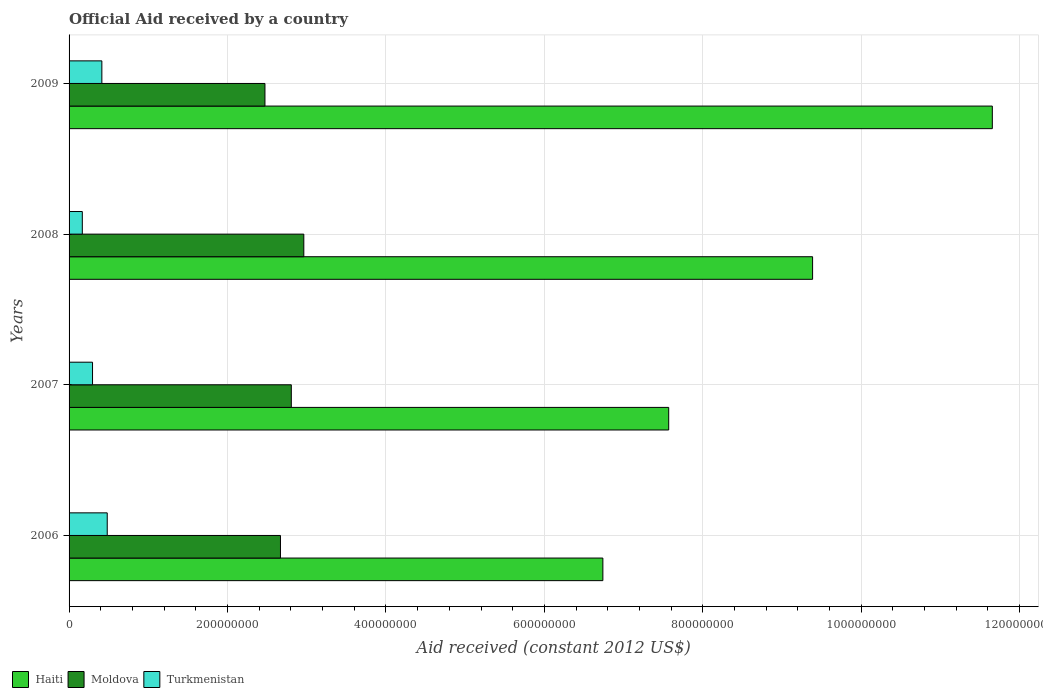How many groups of bars are there?
Offer a very short reply. 4. How many bars are there on the 2nd tick from the top?
Provide a succinct answer. 3. In how many cases, is the number of bars for a given year not equal to the number of legend labels?
Offer a terse response. 0. What is the net official aid received in Haiti in 2008?
Keep it short and to the point. 9.39e+08. Across all years, what is the maximum net official aid received in Turkmenistan?
Ensure brevity in your answer.  4.82e+07. Across all years, what is the minimum net official aid received in Turkmenistan?
Give a very brief answer. 1.67e+07. In which year was the net official aid received in Haiti minimum?
Your answer should be very brief. 2006. What is the total net official aid received in Turkmenistan in the graph?
Your answer should be compact. 1.36e+08. What is the difference between the net official aid received in Haiti in 2008 and that in 2009?
Your response must be concise. -2.27e+08. What is the difference between the net official aid received in Haiti in 2006 and the net official aid received in Turkmenistan in 2009?
Provide a succinct answer. 6.32e+08. What is the average net official aid received in Haiti per year?
Keep it short and to the point. 8.84e+08. In the year 2007, what is the difference between the net official aid received in Haiti and net official aid received in Moldova?
Offer a very short reply. 4.76e+08. What is the ratio of the net official aid received in Moldova in 2006 to that in 2007?
Provide a succinct answer. 0.95. What is the difference between the highest and the second highest net official aid received in Turkmenistan?
Offer a very short reply. 6.78e+06. What is the difference between the highest and the lowest net official aid received in Haiti?
Provide a short and direct response. 4.92e+08. In how many years, is the net official aid received in Moldova greater than the average net official aid received in Moldova taken over all years?
Your response must be concise. 2. What does the 2nd bar from the top in 2009 represents?
Your response must be concise. Moldova. What does the 1st bar from the bottom in 2006 represents?
Keep it short and to the point. Haiti. Are all the bars in the graph horizontal?
Offer a very short reply. Yes. How many years are there in the graph?
Provide a succinct answer. 4. What is the difference between two consecutive major ticks on the X-axis?
Your answer should be compact. 2.00e+08. Are the values on the major ticks of X-axis written in scientific E-notation?
Give a very brief answer. No. How are the legend labels stacked?
Keep it short and to the point. Horizontal. What is the title of the graph?
Provide a succinct answer. Official Aid received by a country. What is the label or title of the X-axis?
Your answer should be compact. Aid received (constant 2012 US$). What is the label or title of the Y-axis?
Your response must be concise. Years. What is the Aid received (constant 2012 US$) in Haiti in 2006?
Your answer should be compact. 6.74e+08. What is the Aid received (constant 2012 US$) in Moldova in 2006?
Offer a very short reply. 2.67e+08. What is the Aid received (constant 2012 US$) in Turkmenistan in 2006?
Make the answer very short. 4.82e+07. What is the Aid received (constant 2012 US$) in Haiti in 2007?
Your answer should be very brief. 7.57e+08. What is the Aid received (constant 2012 US$) of Moldova in 2007?
Provide a short and direct response. 2.81e+08. What is the Aid received (constant 2012 US$) of Turkmenistan in 2007?
Ensure brevity in your answer.  2.96e+07. What is the Aid received (constant 2012 US$) in Haiti in 2008?
Give a very brief answer. 9.39e+08. What is the Aid received (constant 2012 US$) in Moldova in 2008?
Provide a succinct answer. 2.96e+08. What is the Aid received (constant 2012 US$) of Turkmenistan in 2008?
Provide a short and direct response. 1.67e+07. What is the Aid received (constant 2012 US$) of Haiti in 2009?
Your response must be concise. 1.17e+09. What is the Aid received (constant 2012 US$) in Moldova in 2009?
Offer a very short reply. 2.47e+08. What is the Aid received (constant 2012 US$) of Turkmenistan in 2009?
Provide a succinct answer. 4.14e+07. Across all years, what is the maximum Aid received (constant 2012 US$) of Haiti?
Your answer should be very brief. 1.17e+09. Across all years, what is the maximum Aid received (constant 2012 US$) in Moldova?
Keep it short and to the point. 2.96e+08. Across all years, what is the maximum Aid received (constant 2012 US$) in Turkmenistan?
Give a very brief answer. 4.82e+07. Across all years, what is the minimum Aid received (constant 2012 US$) of Haiti?
Your response must be concise. 6.74e+08. Across all years, what is the minimum Aid received (constant 2012 US$) of Moldova?
Provide a short and direct response. 2.47e+08. Across all years, what is the minimum Aid received (constant 2012 US$) in Turkmenistan?
Offer a very short reply. 1.67e+07. What is the total Aid received (constant 2012 US$) of Haiti in the graph?
Make the answer very short. 3.53e+09. What is the total Aid received (constant 2012 US$) of Moldova in the graph?
Provide a succinct answer. 1.09e+09. What is the total Aid received (constant 2012 US$) of Turkmenistan in the graph?
Your answer should be compact. 1.36e+08. What is the difference between the Aid received (constant 2012 US$) of Haiti in 2006 and that in 2007?
Give a very brief answer. -8.31e+07. What is the difference between the Aid received (constant 2012 US$) in Moldova in 2006 and that in 2007?
Your response must be concise. -1.37e+07. What is the difference between the Aid received (constant 2012 US$) of Turkmenistan in 2006 and that in 2007?
Ensure brevity in your answer.  1.86e+07. What is the difference between the Aid received (constant 2012 US$) in Haiti in 2006 and that in 2008?
Offer a terse response. -2.65e+08. What is the difference between the Aid received (constant 2012 US$) in Moldova in 2006 and that in 2008?
Your answer should be compact. -2.95e+07. What is the difference between the Aid received (constant 2012 US$) of Turkmenistan in 2006 and that in 2008?
Keep it short and to the point. 3.15e+07. What is the difference between the Aid received (constant 2012 US$) of Haiti in 2006 and that in 2009?
Ensure brevity in your answer.  -4.92e+08. What is the difference between the Aid received (constant 2012 US$) in Moldova in 2006 and that in 2009?
Provide a succinct answer. 1.96e+07. What is the difference between the Aid received (constant 2012 US$) of Turkmenistan in 2006 and that in 2009?
Your answer should be very brief. 6.78e+06. What is the difference between the Aid received (constant 2012 US$) in Haiti in 2007 and that in 2008?
Offer a terse response. -1.82e+08. What is the difference between the Aid received (constant 2012 US$) in Moldova in 2007 and that in 2008?
Offer a very short reply. -1.58e+07. What is the difference between the Aid received (constant 2012 US$) in Turkmenistan in 2007 and that in 2008?
Offer a terse response. 1.29e+07. What is the difference between the Aid received (constant 2012 US$) in Haiti in 2007 and that in 2009?
Your answer should be compact. -4.09e+08. What is the difference between the Aid received (constant 2012 US$) of Moldova in 2007 and that in 2009?
Provide a short and direct response. 3.33e+07. What is the difference between the Aid received (constant 2012 US$) in Turkmenistan in 2007 and that in 2009?
Provide a succinct answer. -1.18e+07. What is the difference between the Aid received (constant 2012 US$) of Haiti in 2008 and that in 2009?
Keep it short and to the point. -2.27e+08. What is the difference between the Aid received (constant 2012 US$) in Moldova in 2008 and that in 2009?
Offer a terse response. 4.91e+07. What is the difference between the Aid received (constant 2012 US$) in Turkmenistan in 2008 and that in 2009?
Keep it short and to the point. -2.47e+07. What is the difference between the Aid received (constant 2012 US$) of Haiti in 2006 and the Aid received (constant 2012 US$) of Moldova in 2007?
Provide a succinct answer. 3.93e+08. What is the difference between the Aid received (constant 2012 US$) of Haiti in 2006 and the Aid received (constant 2012 US$) of Turkmenistan in 2007?
Offer a terse response. 6.44e+08. What is the difference between the Aid received (constant 2012 US$) of Moldova in 2006 and the Aid received (constant 2012 US$) of Turkmenistan in 2007?
Your answer should be compact. 2.37e+08. What is the difference between the Aid received (constant 2012 US$) of Haiti in 2006 and the Aid received (constant 2012 US$) of Moldova in 2008?
Provide a succinct answer. 3.78e+08. What is the difference between the Aid received (constant 2012 US$) of Haiti in 2006 and the Aid received (constant 2012 US$) of Turkmenistan in 2008?
Keep it short and to the point. 6.57e+08. What is the difference between the Aid received (constant 2012 US$) in Moldova in 2006 and the Aid received (constant 2012 US$) in Turkmenistan in 2008?
Keep it short and to the point. 2.50e+08. What is the difference between the Aid received (constant 2012 US$) in Haiti in 2006 and the Aid received (constant 2012 US$) in Moldova in 2009?
Give a very brief answer. 4.27e+08. What is the difference between the Aid received (constant 2012 US$) in Haiti in 2006 and the Aid received (constant 2012 US$) in Turkmenistan in 2009?
Provide a short and direct response. 6.32e+08. What is the difference between the Aid received (constant 2012 US$) in Moldova in 2006 and the Aid received (constant 2012 US$) in Turkmenistan in 2009?
Make the answer very short. 2.25e+08. What is the difference between the Aid received (constant 2012 US$) of Haiti in 2007 and the Aid received (constant 2012 US$) of Moldova in 2008?
Keep it short and to the point. 4.61e+08. What is the difference between the Aid received (constant 2012 US$) in Haiti in 2007 and the Aid received (constant 2012 US$) in Turkmenistan in 2008?
Offer a very short reply. 7.40e+08. What is the difference between the Aid received (constant 2012 US$) of Moldova in 2007 and the Aid received (constant 2012 US$) of Turkmenistan in 2008?
Your answer should be very brief. 2.64e+08. What is the difference between the Aid received (constant 2012 US$) in Haiti in 2007 and the Aid received (constant 2012 US$) in Moldova in 2009?
Keep it short and to the point. 5.10e+08. What is the difference between the Aid received (constant 2012 US$) of Haiti in 2007 and the Aid received (constant 2012 US$) of Turkmenistan in 2009?
Keep it short and to the point. 7.16e+08. What is the difference between the Aid received (constant 2012 US$) in Moldova in 2007 and the Aid received (constant 2012 US$) in Turkmenistan in 2009?
Ensure brevity in your answer.  2.39e+08. What is the difference between the Aid received (constant 2012 US$) of Haiti in 2008 and the Aid received (constant 2012 US$) of Moldova in 2009?
Your answer should be compact. 6.91e+08. What is the difference between the Aid received (constant 2012 US$) in Haiti in 2008 and the Aid received (constant 2012 US$) in Turkmenistan in 2009?
Give a very brief answer. 8.97e+08. What is the difference between the Aid received (constant 2012 US$) of Moldova in 2008 and the Aid received (constant 2012 US$) of Turkmenistan in 2009?
Your response must be concise. 2.55e+08. What is the average Aid received (constant 2012 US$) of Haiti per year?
Ensure brevity in your answer.  8.84e+08. What is the average Aid received (constant 2012 US$) of Moldova per year?
Provide a short and direct response. 2.73e+08. What is the average Aid received (constant 2012 US$) in Turkmenistan per year?
Make the answer very short. 3.40e+07. In the year 2006, what is the difference between the Aid received (constant 2012 US$) in Haiti and Aid received (constant 2012 US$) in Moldova?
Make the answer very short. 4.07e+08. In the year 2006, what is the difference between the Aid received (constant 2012 US$) of Haiti and Aid received (constant 2012 US$) of Turkmenistan?
Offer a terse response. 6.26e+08. In the year 2006, what is the difference between the Aid received (constant 2012 US$) in Moldova and Aid received (constant 2012 US$) in Turkmenistan?
Your response must be concise. 2.19e+08. In the year 2007, what is the difference between the Aid received (constant 2012 US$) of Haiti and Aid received (constant 2012 US$) of Moldova?
Your response must be concise. 4.76e+08. In the year 2007, what is the difference between the Aid received (constant 2012 US$) of Haiti and Aid received (constant 2012 US$) of Turkmenistan?
Ensure brevity in your answer.  7.27e+08. In the year 2007, what is the difference between the Aid received (constant 2012 US$) of Moldova and Aid received (constant 2012 US$) of Turkmenistan?
Your response must be concise. 2.51e+08. In the year 2008, what is the difference between the Aid received (constant 2012 US$) in Haiti and Aid received (constant 2012 US$) in Moldova?
Ensure brevity in your answer.  6.42e+08. In the year 2008, what is the difference between the Aid received (constant 2012 US$) of Haiti and Aid received (constant 2012 US$) of Turkmenistan?
Your answer should be compact. 9.22e+08. In the year 2008, what is the difference between the Aid received (constant 2012 US$) of Moldova and Aid received (constant 2012 US$) of Turkmenistan?
Offer a terse response. 2.80e+08. In the year 2009, what is the difference between the Aid received (constant 2012 US$) of Haiti and Aid received (constant 2012 US$) of Moldova?
Give a very brief answer. 9.18e+08. In the year 2009, what is the difference between the Aid received (constant 2012 US$) of Haiti and Aid received (constant 2012 US$) of Turkmenistan?
Your answer should be very brief. 1.12e+09. In the year 2009, what is the difference between the Aid received (constant 2012 US$) of Moldova and Aid received (constant 2012 US$) of Turkmenistan?
Make the answer very short. 2.06e+08. What is the ratio of the Aid received (constant 2012 US$) in Haiti in 2006 to that in 2007?
Your response must be concise. 0.89. What is the ratio of the Aid received (constant 2012 US$) of Moldova in 2006 to that in 2007?
Provide a succinct answer. 0.95. What is the ratio of the Aid received (constant 2012 US$) of Turkmenistan in 2006 to that in 2007?
Give a very brief answer. 1.63. What is the ratio of the Aid received (constant 2012 US$) of Haiti in 2006 to that in 2008?
Your response must be concise. 0.72. What is the ratio of the Aid received (constant 2012 US$) in Moldova in 2006 to that in 2008?
Provide a short and direct response. 0.9. What is the ratio of the Aid received (constant 2012 US$) in Turkmenistan in 2006 to that in 2008?
Your answer should be very brief. 2.88. What is the ratio of the Aid received (constant 2012 US$) of Haiti in 2006 to that in 2009?
Provide a succinct answer. 0.58. What is the ratio of the Aid received (constant 2012 US$) in Moldova in 2006 to that in 2009?
Give a very brief answer. 1.08. What is the ratio of the Aid received (constant 2012 US$) of Turkmenistan in 2006 to that in 2009?
Your answer should be compact. 1.16. What is the ratio of the Aid received (constant 2012 US$) in Haiti in 2007 to that in 2008?
Make the answer very short. 0.81. What is the ratio of the Aid received (constant 2012 US$) of Moldova in 2007 to that in 2008?
Your answer should be compact. 0.95. What is the ratio of the Aid received (constant 2012 US$) of Turkmenistan in 2007 to that in 2008?
Provide a short and direct response. 1.77. What is the ratio of the Aid received (constant 2012 US$) in Haiti in 2007 to that in 2009?
Your answer should be very brief. 0.65. What is the ratio of the Aid received (constant 2012 US$) in Moldova in 2007 to that in 2009?
Make the answer very short. 1.13. What is the ratio of the Aid received (constant 2012 US$) in Turkmenistan in 2007 to that in 2009?
Your answer should be very brief. 0.72. What is the ratio of the Aid received (constant 2012 US$) of Haiti in 2008 to that in 2009?
Your answer should be very brief. 0.81. What is the ratio of the Aid received (constant 2012 US$) in Moldova in 2008 to that in 2009?
Your answer should be very brief. 1.2. What is the ratio of the Aid received (constant 2012 US$) of Turkmenistan in 2008 to that in 2009?
Keep it short and to the point. 0.4. What is the difference between the highest and the second highest Aid received (constant 2012 US$) of Haiti?
Provide a short and direct response. 2.27e+08. What is the difference between the highest and the second highest Aid received (constant 2012 US$) in Moldova?
Your answer should be compact. 1.58e+07. What is the difference between the highest and the second highest Aid received (constant 2012 US$) of Turkmenistan?
Give a very brief answer. 6.78e+06. What is the difference between the highest and the lowest Aid received (constant 2012 US$) in Haiti?
Your answer should be very brief. 4.92e+08. What is the difference between the highest and the lowest Aid received (constant 2012 US$) of Moldova?
Offer a terse response. 4.91e+07. What is the difference between the highest and the lowest Aid received (constant 2012 US$) in Turkmenistan?
Provide a succinct answer. 3.15e+07. 